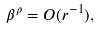Convert formula to latex. <formula><loc_0><loc_0><loc_500><loc_500>\beta ^ { \rho } = O ( r ^ { - 1 } ) ,</formula> 